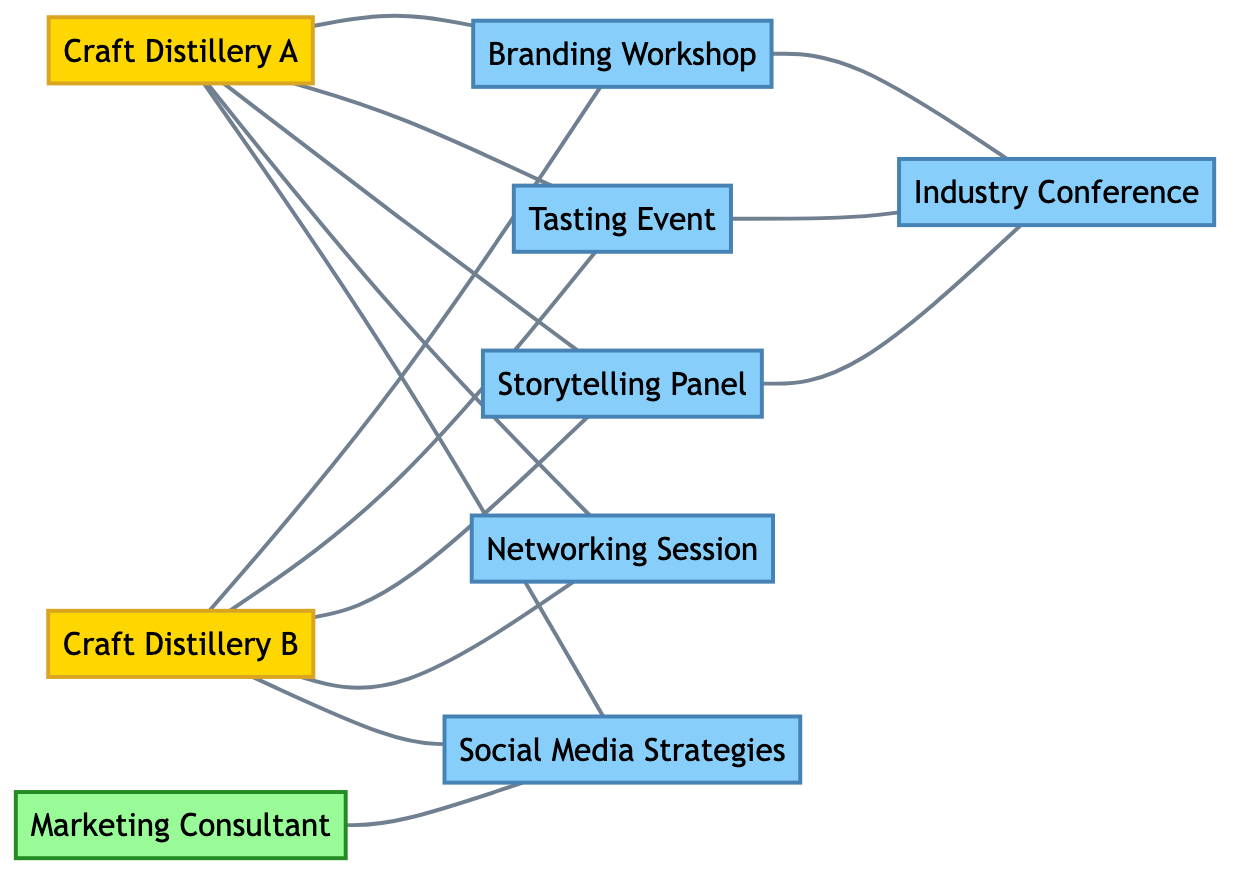What is the total number of nodes in the diagram? To find the total number of nodes, we count each unique entity listed in the "nodes" section. There are 8 nodes: Craft Distillery A, Craft Distillery B, Marketing Consultant, Branding Workshop, Tasting Event, Storytelling Panel, Industry Conference, and Networking Session.
Answer: 8 Which two craft distilleries are connected to the Branding Workshop? We check the edges for any connections to the Branding Workshop by looking for where it is listed as a target. The edges show connections from both Craft Distillery A and Craft Distillery B to the Branding Workshop.
Answer: Craft Distillery A and Craft Distillery B How many events are connected to the Industry Conference? Looking at the edges, we can find how many events are named and are connected to the Industry Conference. There are three events that connect: Branding Workshop, Tasting Event, and Storytelling Panel.
Answer: 3 Which node has connections to both Craft Distillery A and Craft Distillery B? We examine the edges that show relationships between nodes. The nodes that have direct edges connecting to both Craft Distillery A and Craft Distillery B include Branding Workshop, Tasting Event, Storytelling Panel, Networking Session, and Social Media Strategies.
Answer: Branding Workshop, Tasting Event, Storytelling Panel, Networking Session, Social Media Strategies What type of events are connected to Craft Distillery A? We look at the edges connected to Craft Distillery A and categorize the connected nodes labeled as events. The events connected to Craft Distillery A are Branding Workshop, Tasting Event, Storytelling Panel, Networking Session, and Social Media Strategies.
Answer: Branding Workshop, Tasting Event, Storytelling Panel, Networking Session, Social Media Strategies Is the Marketing Consultant connected to any craft distilleries? To answer this, we check the edges that involve the Marketing Consultant and see if there are direct connections (edges) to either Craft Distillery A or Craft Distillery B. The Marketing Consultant is connected to Social Media Strategies but not directly to either craft distillery.
Answer: No How many unique types of interactions (edges) are present in the diagram? To find the unique interactions, we count the edges listed in the "edges" section. There are a total of 12 edges connecting various nodes, representing interactions among different participants and events.
Answer: 12 Which event has the most connections in the diagram? We count the number of edges for each event node. The Industry Conference is connected to three different events: Branding Workshop, Tasting Event, and Storytelling Panel, while the others vary in their connections.
Answer: Industry Conference What role does the Marketing Consultant play in the diagram? By analyzing the connections, we see the Marketing Consultant's primary connection is to Social Media Strategies. It suggests a role related to advising or sharing knowledge about social media within craft distilleries.
Answer: Advisor on Social Media Strategies 